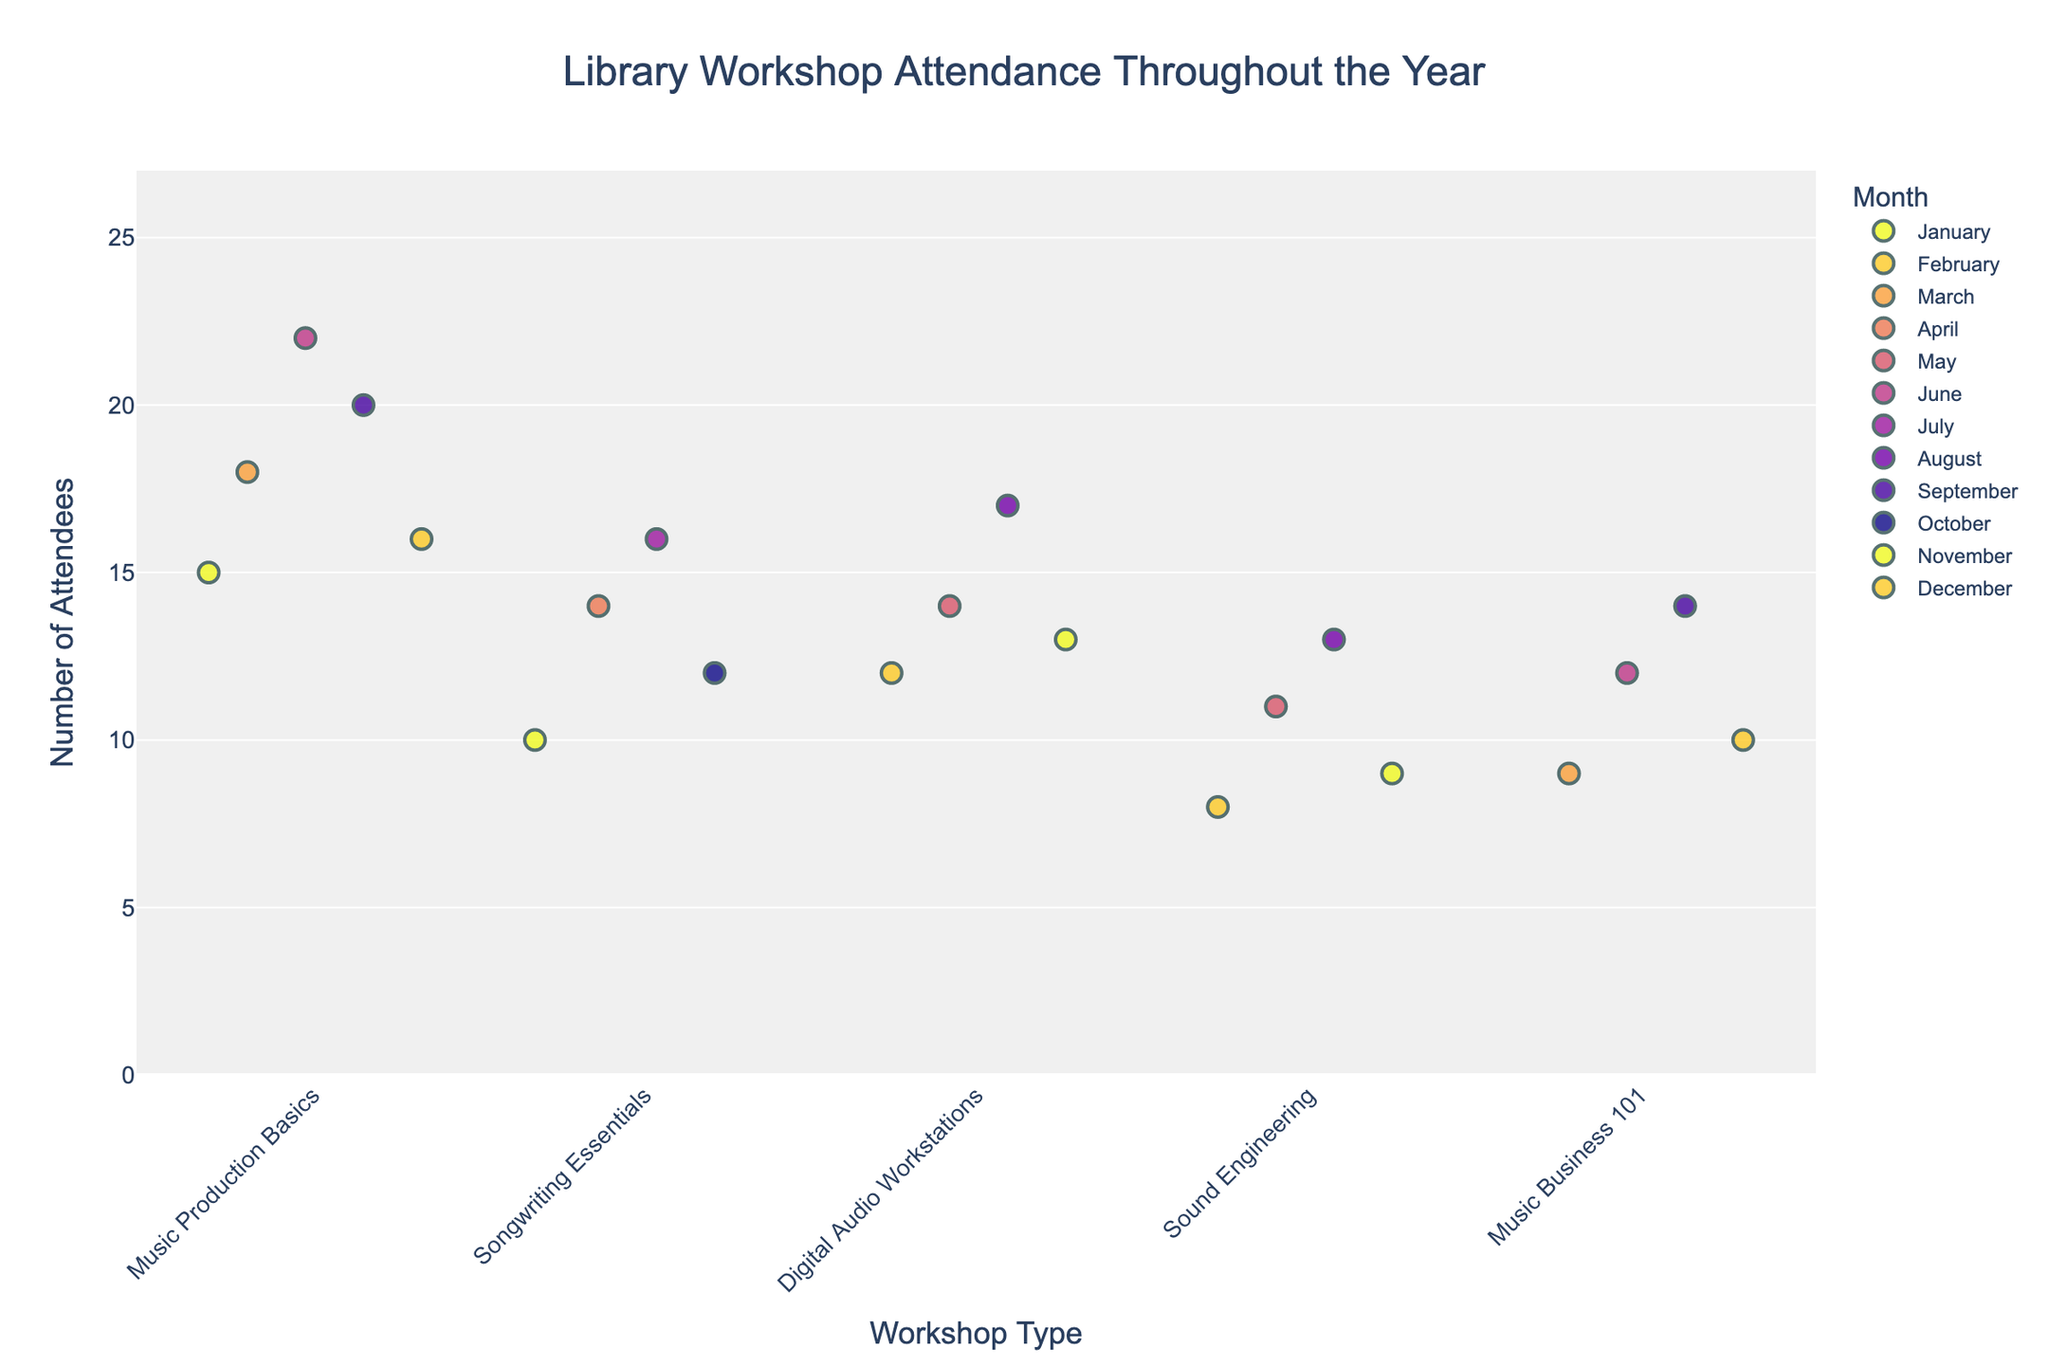What's the title of the figure? The title is located at the top of the figure and provides an overview of what the plot is about.
Answer: Library Workshop Attendance Throughout the Year Which workshop had the highest attendance? By visually examining the strip plot, we look for the data point that vertically reaches the highest value on the y-axis.
Answer: Music Production Basics How does the attendance of "Music Business 101" in December compare to that in September? Locate the data points for "Music Business 101" in both December and September on the strip plot and compare their y-values.
Answer: Lower in December Which month shows the most variability in attendance for "Digital Audio Workstations"? By observing the spread of data points for "Digital Audio Workstations" across different months, we find the month with the widest range.
Answer: August What is the average attendance for "Sound Engineering" workshops? Identify all data points for "Sound Engineering" on the plot, sum their y-values, and divide by the number of points. (8 + 11 + 13 + 9) / 4 = 10.25
Answer: 10.25 Are there any months where the attendance for "Songwriting Essentials" is the same? Look at the data points for "Songwriting Essentials" and identify any overlapping y-values corresponding to different months.
Answer: No Which workshop has the least variance in attendance throughout the year? Assess the spread of data points for each workshop. Smaller vertical spread indicates less variance.
Answer: Music Business 101 What is the difference in the highest and lowest attendance for "Music Production Basics"? Find the maximum and minimum y-values for "Music Production Basics" and calculate the difference. 22 - 15 = 7
Answer: 7 Is there a month when "Digital Audio Workstations" has higher attendance than any "Sound Engineering" workshop? Compare the highest y-value of "Sound Engineering" with all the y-values of "Digital Audio Workstations." The highest for "Sound Engineering" is 13, and for "Digital Audio Workstations" it goes up to 17 in August.
Answer: Yes What is the median attendance for "Songwriting Essentials"? Organize the y-values for "Songwriting Essentials": (10, 12, 14, 16), find the pair of middlemost numbers and calculate their average. (12 + 14) / 2 = 13
Answer: 13 